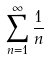<formula> <loc_0><loc_0><loc_500><loc_500>\sum _ { n = 1 } ^ { \infty } \frac { 1 } { n }</formula> 